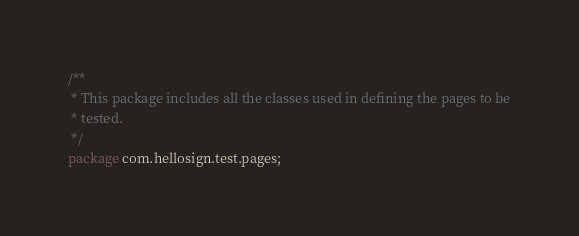<code> <loc_0><loc_0><loc_500><loc_500><_Java_>/**
 * This package includes all the classes used in defining the pages to be
 * tested.
 */
package com.hellosign.test.pages;
</code> 